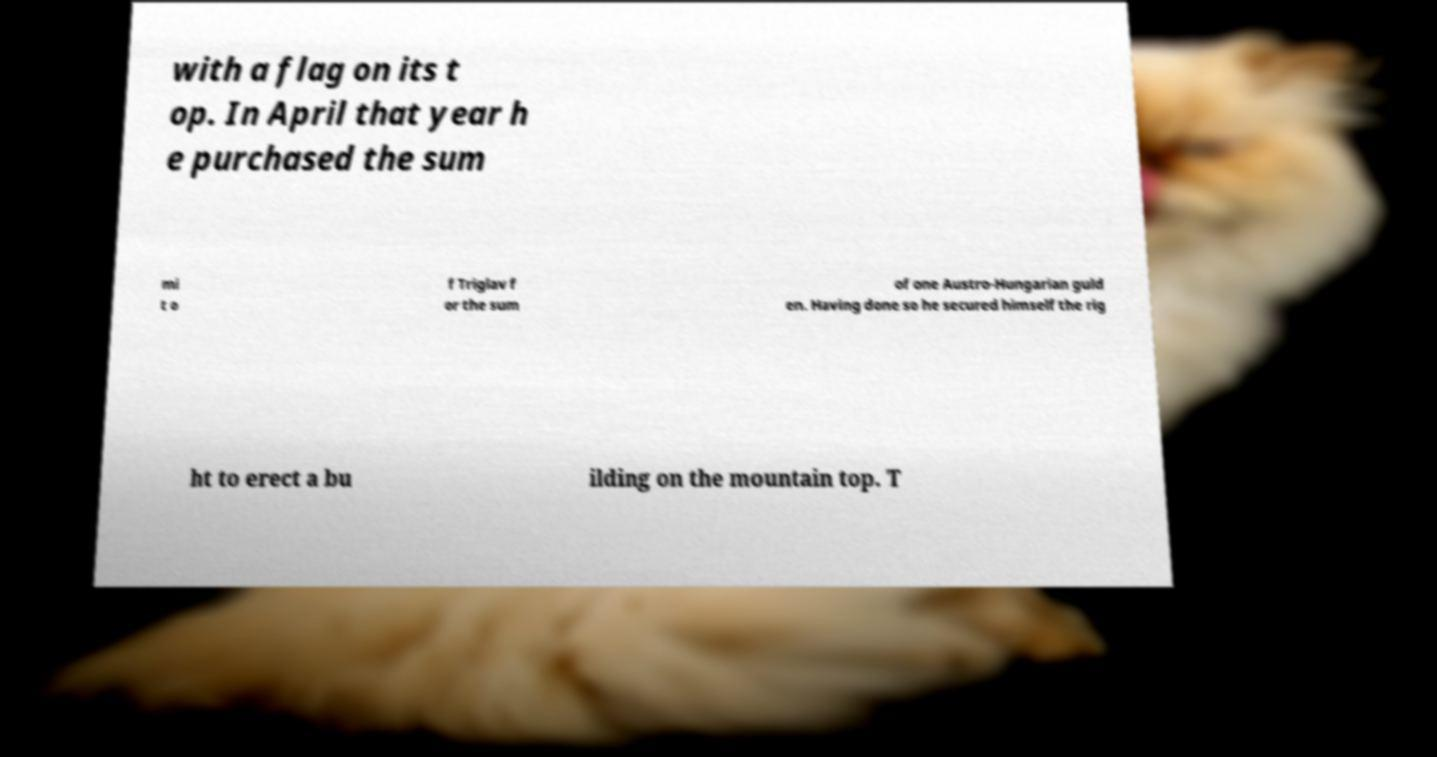Could you extract and type out the text from this image? with a flag on its t op. In April that year h e purchased the sum mi t o f Triglav f or the sum of one Austro-Hungarian guld en. Having done so he secured himself the rig ht to erect a bu ilding on the mountain top. T 